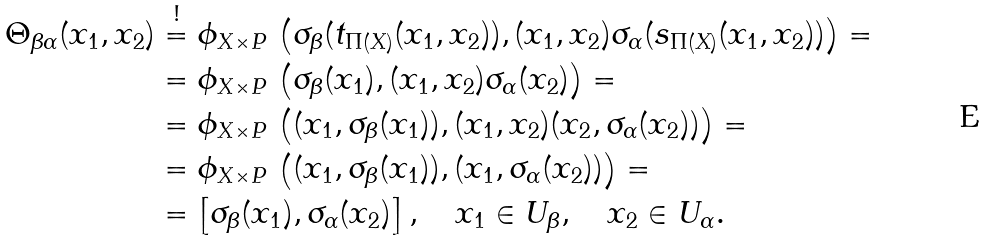<formula> <loc_0><loc_0><loc_500><loc_500>\Theta _ { \beta \alpha } ( x _ { 1 } , x _ { 2 } ) & \overset { ! } = \phi _ { X \times P } \, \left ( \sigma _ { \beta } ( t _ { \Pi ( X ) } ( x _ { 1 } , x _ { 2 } ) ) , ( x _ { 1 } , x _ { 2 } ) \sigma _ { \alpha } ( s _ { \Pi ( X ) } ( x _ { 1 } , x _ { 2 } ) ) \right ) = \\ & = \phi _ { X \times P } \, \left ( \sigma _ { \beta } ( x _ { 1 } ) , ( x _ { 1 } , x _ { 2 } ) \sigma _ { \alpha } ( x _ { 2 } ) \right ) = \\ & = \phi _ { X \times P } \, \left ( ( x _ { 1 } , \sigma _ { \beta } ( x _ { 1 } ) ) , ( x _ { 1 } , x _ { 2 } ) ( x _ { 2 } , \sigma _ { \alpha } ( x _ { 2 } ) ) \right ) = \\ & = \phi _ { X \times P } \, \left ( ( x _ { 1 } , \sigma _ { \beta } ( x _ { 1 } ) ) , ( x _ { 1 } , \sigma _ { \alpha } ( x _ { 2 } ) ) \right ) = \\ & = \left [ \sigma _ { \beta } ( x _ { 1 } ) , \sigma _ { \alpha } ( x _ { 2 } ) \right ] , \quad x _ { 1 } \in U _ { \beta } , \quad x _ { 2 } \in U _ { \alpha } .</formula> 